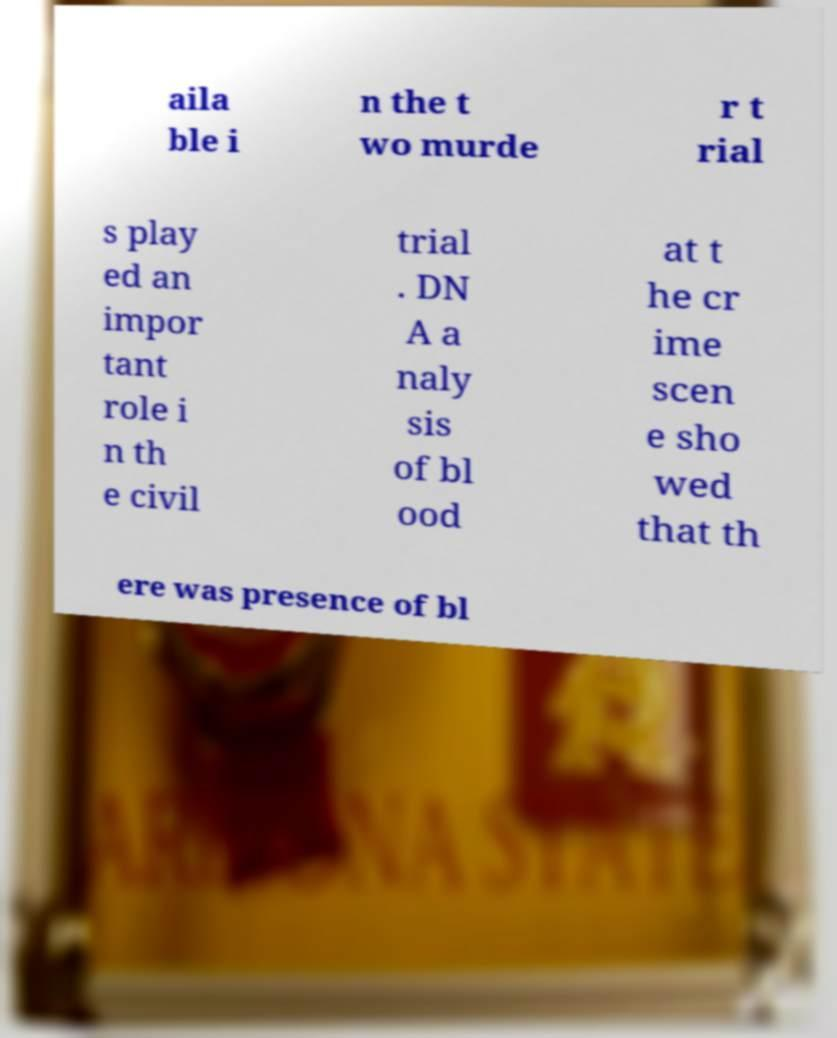There's text embedded in this image that I need extracted. Can you transcribe it verbatim? aila ble i n the t wo murde r t rial s play ed an impor tant role i n th e civil trial . DN A a naly sis of bl ood at t he cr ime scen e sho wed that th ere was presence of bl 